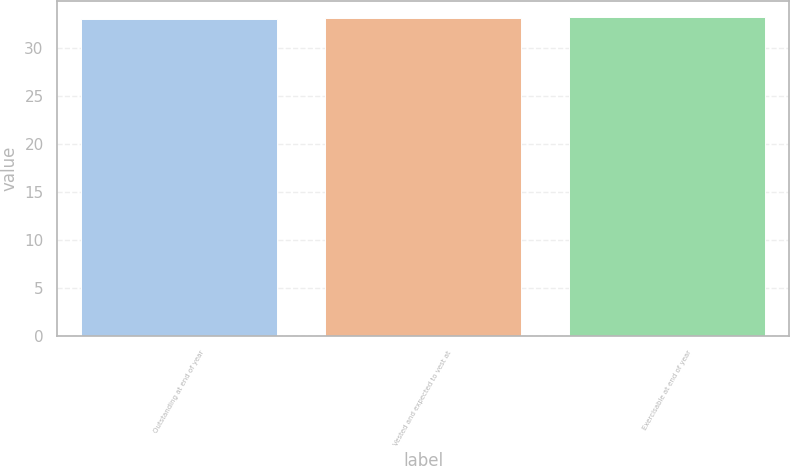<chart> <loc_0><loc_0><loc_500><loc_500><bar_chart><fcel>Outstanding at end of year<fcel>Vested and expected to vest at<fcel>Exercisable at end of year<nl><fcel>33<fcel>33.1<fcel>33.2<nl></chart> 